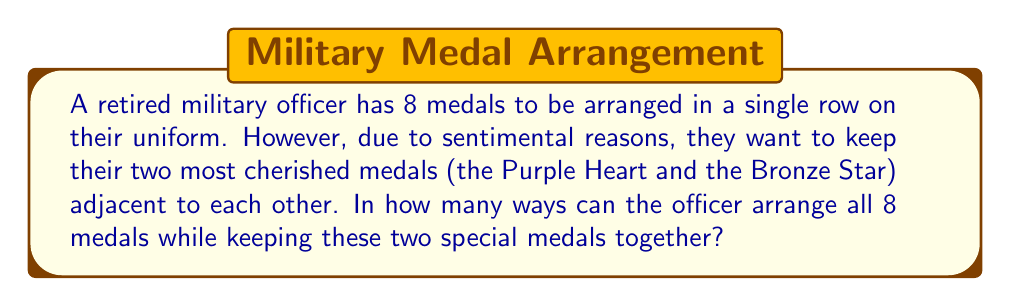Could you help me with this problem? Let's approach this step-by-step:

1) First, we can consider the Purple Heart and Bronze Star as a single unit. This reduces our problem to arranging 7 units (the combined medal unit plus the other 6 medals).

2) We can arrange 7 units in $7!$ ways.

3) However, we also need to consider the arrangements of the two special medals within their unit. They can be arranged in $2!$ ways.

4) By the multiplication principle, the total number of arrangements is:

   $$7! \times 2!$$

5) Let's calculate this:
   
   $$7! \times 2! = 5040 \times 2 = 10080$$

Thus, there are 10,080 ways to arrange the medals while keeping the Purple Heart and Bronze Star adjacent.
Answer: $10080$ 